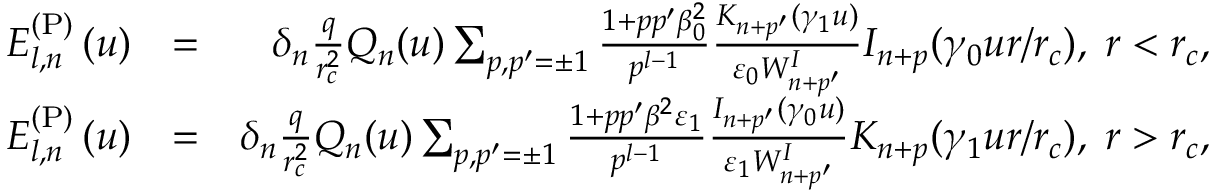<formula> <loc_0><loc_0><loc_500><loc_500>\begin{array} { r l r } { E _ { l , n } ^ { ( P ) } \left ( u \right ) } & { = } & { \delta _ { n } \frac { q } { r _ { c } ^ { 2 } } Q _ { n } ( u ) \sum _ { p , p ^ { \prime } = \pm 1 } \frac { 1 + p p ^ { \prime } \beta _ { 0 } ^ { 2 } } { p ^ { l - 1 } } \frac { K _ { n + p ^ { \prime } } ( \gamma _ { 1 } u ) } { \varepsilon _ { 0 } W _ { n + p ^ { \prime } } ^ { I } } I _ { n + p } ( \gamma _ { 0 } u r / r _ { c } ) , \, r < r _ { c } , } \\ { E _ { l , n } ^ { ( P ) } \left ( u \right ) } & { = } & { \delta _ { n } \frac { q } { r _ { c } ^ { 2 } } Q _ { n } ( u ) \sum _ { p , p ^ { \prime } = \pm 1 } \frac { 1 + p p ^ { \prime } \beta ^ { 2 } \varepsilon _ { 1 } } { p ^ { l - 1 } } \frac { I _ { n + p ^ { \prime } } ( \gamma _ { 0 } u ) } { \varepsilon _ { 1 } W _ { n + p ^ { \prime } } ^ { I } } K _ { n + p } ( \gamma _ { 1 } u r / r _ { c } ) , \, r > r _ { c } , } \end{array}</formula> 